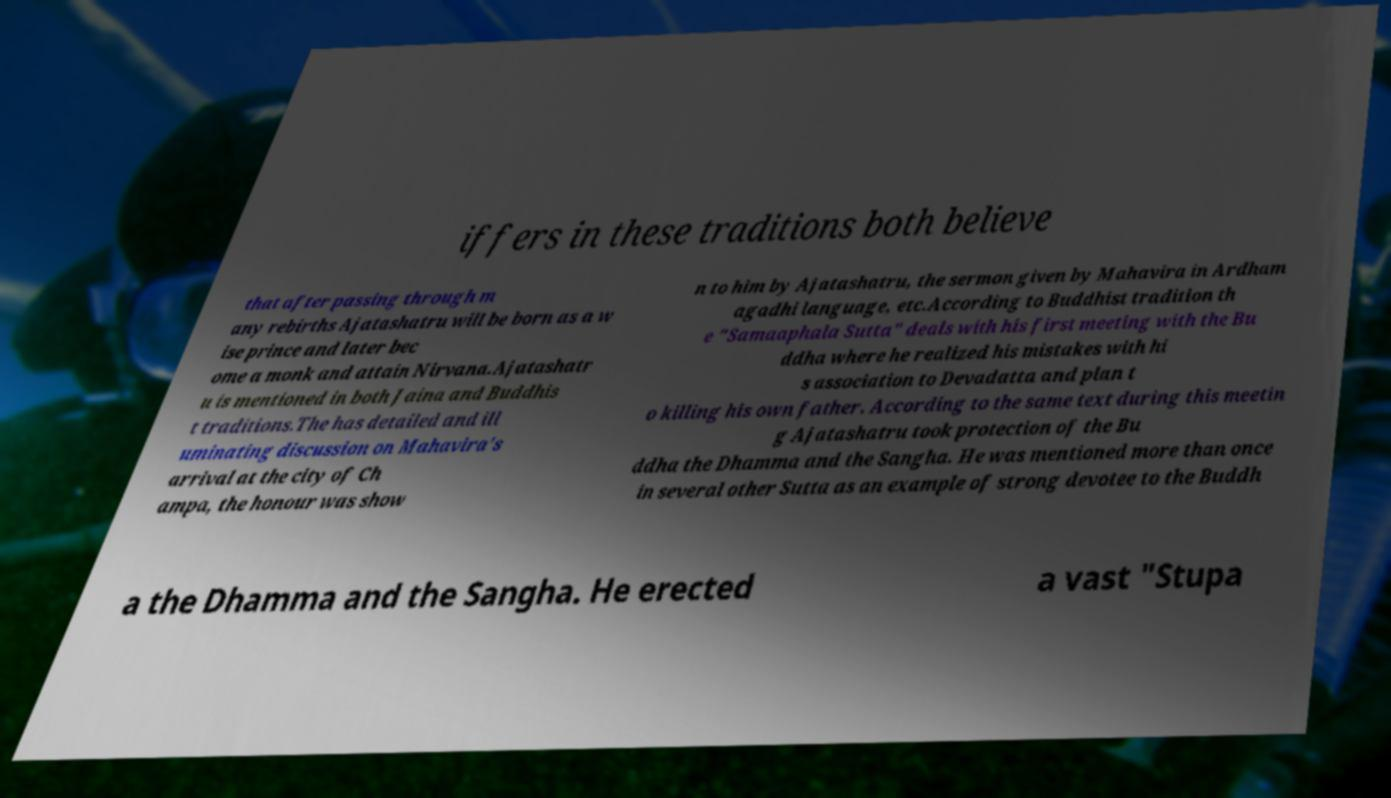Can you read and provide the text displayed in the image?This photo seems to have some interesting text. Can you extract and type it out for me? iffers in these traditions both believe that after passing through m any rebirths Ajatashatru will be born as a w ise prince and later bec ome a monk and attain Nirvana.Ajatashatr u is mentioned in both Jaina and Buddhis t traditions.The has detailed and ill uminating discussion on Mahavira's arrival at the city of Ch ampa, the honour was show n to him by Ajatashatru, the sermon given by Mahavira in Ardham agadhi language, etc.According to Buddhist tradition th e "Samaaphala Sutta" deals with his first meeting with the Bu ddha where he realized his mistakes with hi s association to Devadatta and plan t o killing his own father. According to the same text during this meetin g Ajatashatru took protection of the Bu ddha the Dhamma and the Sangha. He was mentioned more than once in several other Sutta as an example of strong devotee to the Buddh a the Dhamma and the Sangha. He erected a vast "Stupa 